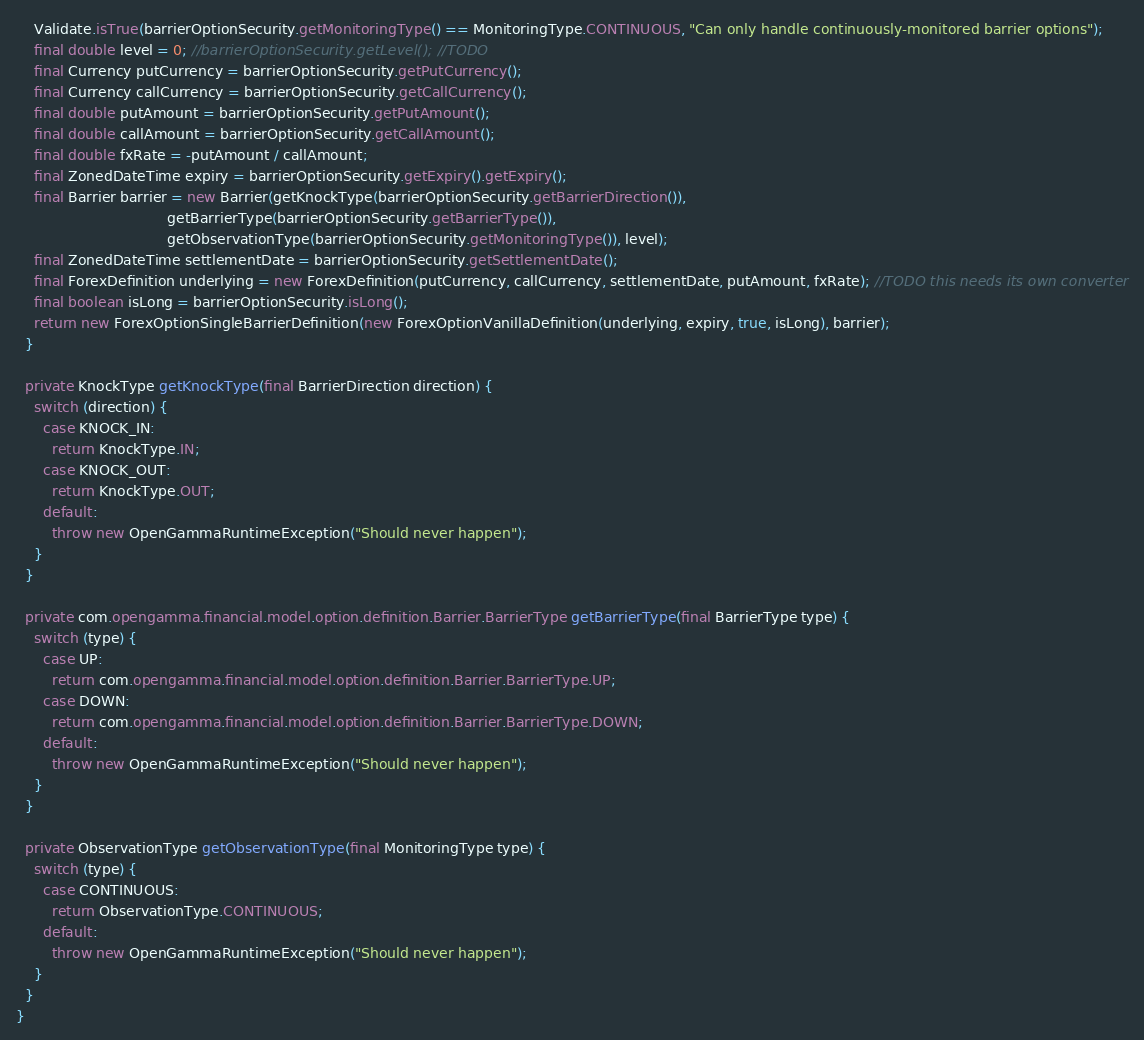<code> <loc_0><loc_0><loc_500><loc_500><_Java_>    Validate.isTrue(barrierOptionSecurity.getMonitoringType() == MonitoringType.CONTINUOUS, "Can only handle continuously-monitored barrier options");
    final double level = 0; //barrierOptionSecurity.getLevel(); //TODO
    final Currency putCurrency = barrierOptionSecurity.getPutCurrency();
    final Currency callCurrency = barrierOptionSecurity.getCallCurrency();
    final double putAmount = barrierOptionSecurity.getPutAmount();
    final double callAmount = barrierOptionSecurity.getCallAmount();
    final double fxRate = -putAmount / callAmount;
    final ZonedDateTime expiry = barrierOptionSecurity.getExpiry().getExpiry();
    final Barrier barrier = new Barrier(getKnockType(barrierOptionSecurity.getBarrierDirection()),
                                  getBarrierType(barrierOptionSecurity.getBarrierType()),
                                  getObservationType(barrierOptionSecurity.getMonitoringType()), level);
    final ZonedDateTime settlementDate = barrierOptionSecurity.getSettlementDate();
    final ForexDefinition underlying = new ForexDefinition(putCurrency, callCurrency, settlementDate, putAmount, fxRate); //TODO this needs its own converter
    final boolean isLong = barrierOptionSecurity.isLong();
    return new ForexOptionSingleBarrierDefinition(new ForexOptionVanillaDefinition(underlying, expiry, true, isLong), barrier);
  }

  private KnockType getKnockType(final BarrierDirection direction) {
    switch (direction) {
      case KNOCK_IN:
        return KnockType.IN;
      case KNOCK_OUT:
        return KnockType.OUT;
      default:
        throw new OpenGammaRuntimeException("Should never happen");
    }
  }

  private com.opengamma.financial.model.option.definition.Barrier.BarrierType getBarrierType(final BarrierType type) {
    switch (type) {
      case UP:
        return com.opengamma.financial.model.option.definition.Barrier.BarrierType.UP;
      case DOWN:
        return com.opengamma.financial.model.option.definition.Barrier.BarrierType.DOWN;
      default:
        throw new OpenGammaRuntimeException("Should never happen");
    }
  }

  private ObservationType getObservationType(final MonitoringType type) {
    switch (type) {
      case CONTINUOUS:
        return ObservationType.CONTINUOUS;
      default:
        throw new OpenGammaRuntimeException("Should never happen");
    }
  }
}
</code> 